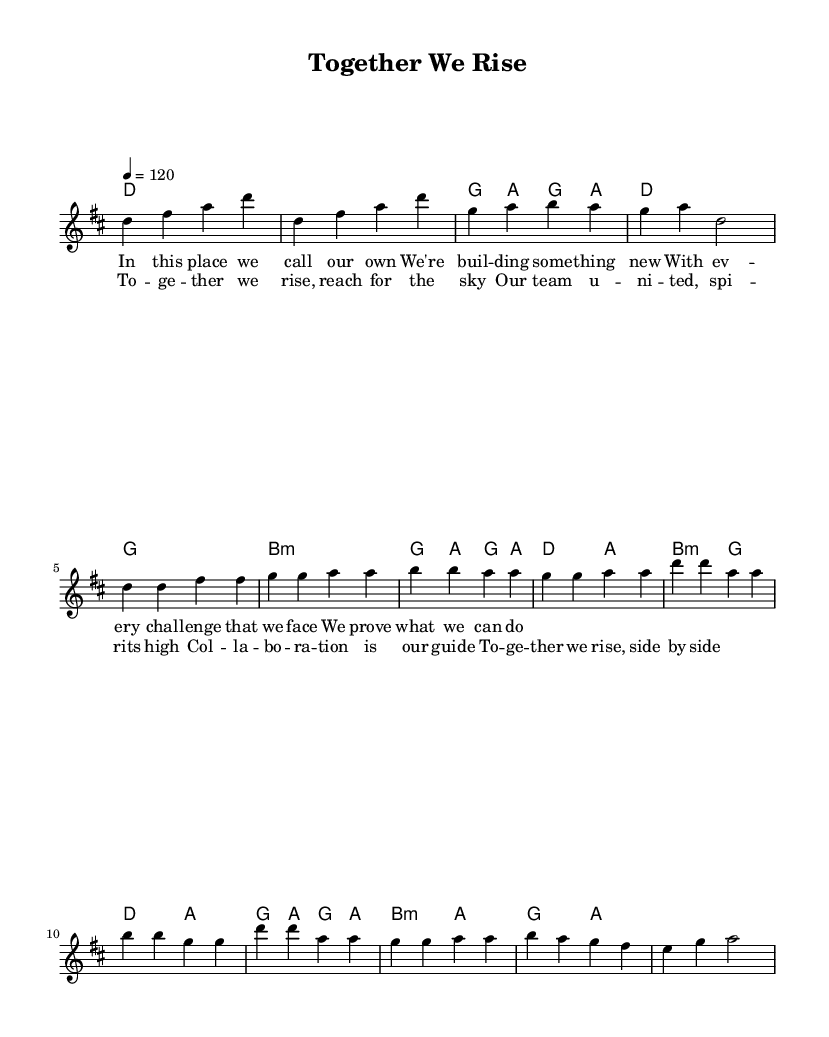What is the key signature of this music? The key signature indicates D major, which has two sharps (F# and C#). You can find this at the beginning of the staff where the sharps are indicated.
Answer: D major What is the time signature of this music? The time signature is at the start of the sheet music and is shown as 4/4, meaning there are four beats in a measure and the quarter note gets one beat.
Answer: 4/4 What is the tempo marking for this piece? The tempo marking is typically found near the top of the score, indicating a speed of 120 beats per minute, specifically noted as "4 = 120".
Answer: 120 How many measures are in the verse section? To find the number of measures, count each individual grouping of bars in the verse section, which contains four measures.
Answer: 4 What is the primary theme of the chorus? The primary theme of the chorus focuses on unity and collaboration, as reflected in the lyrics that celebrate teamwork and rising together.
Answer: Unity What are the first two notes of the melody? The first two notes of the melody, as shown at the beginning of the score, are D and F#, which are the first two notes played sequentially in the melody.
Answer: D, F# What chord follows the first measure of the bridge? The first measure of the bridge indicates a B minor chord. This can be determined by looking at the chord changes stated above the staff in the harmonies section.
Answer: B minor 